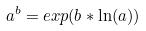<formula> <loc_0><loc_0><loc_500><loc_500>a ^ { b } = e x p ( b * \ln ( a ) )</formula> 